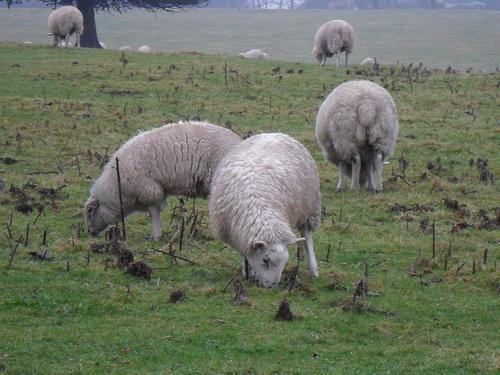How many sheep are there?
Give a very brief answer. 5. 